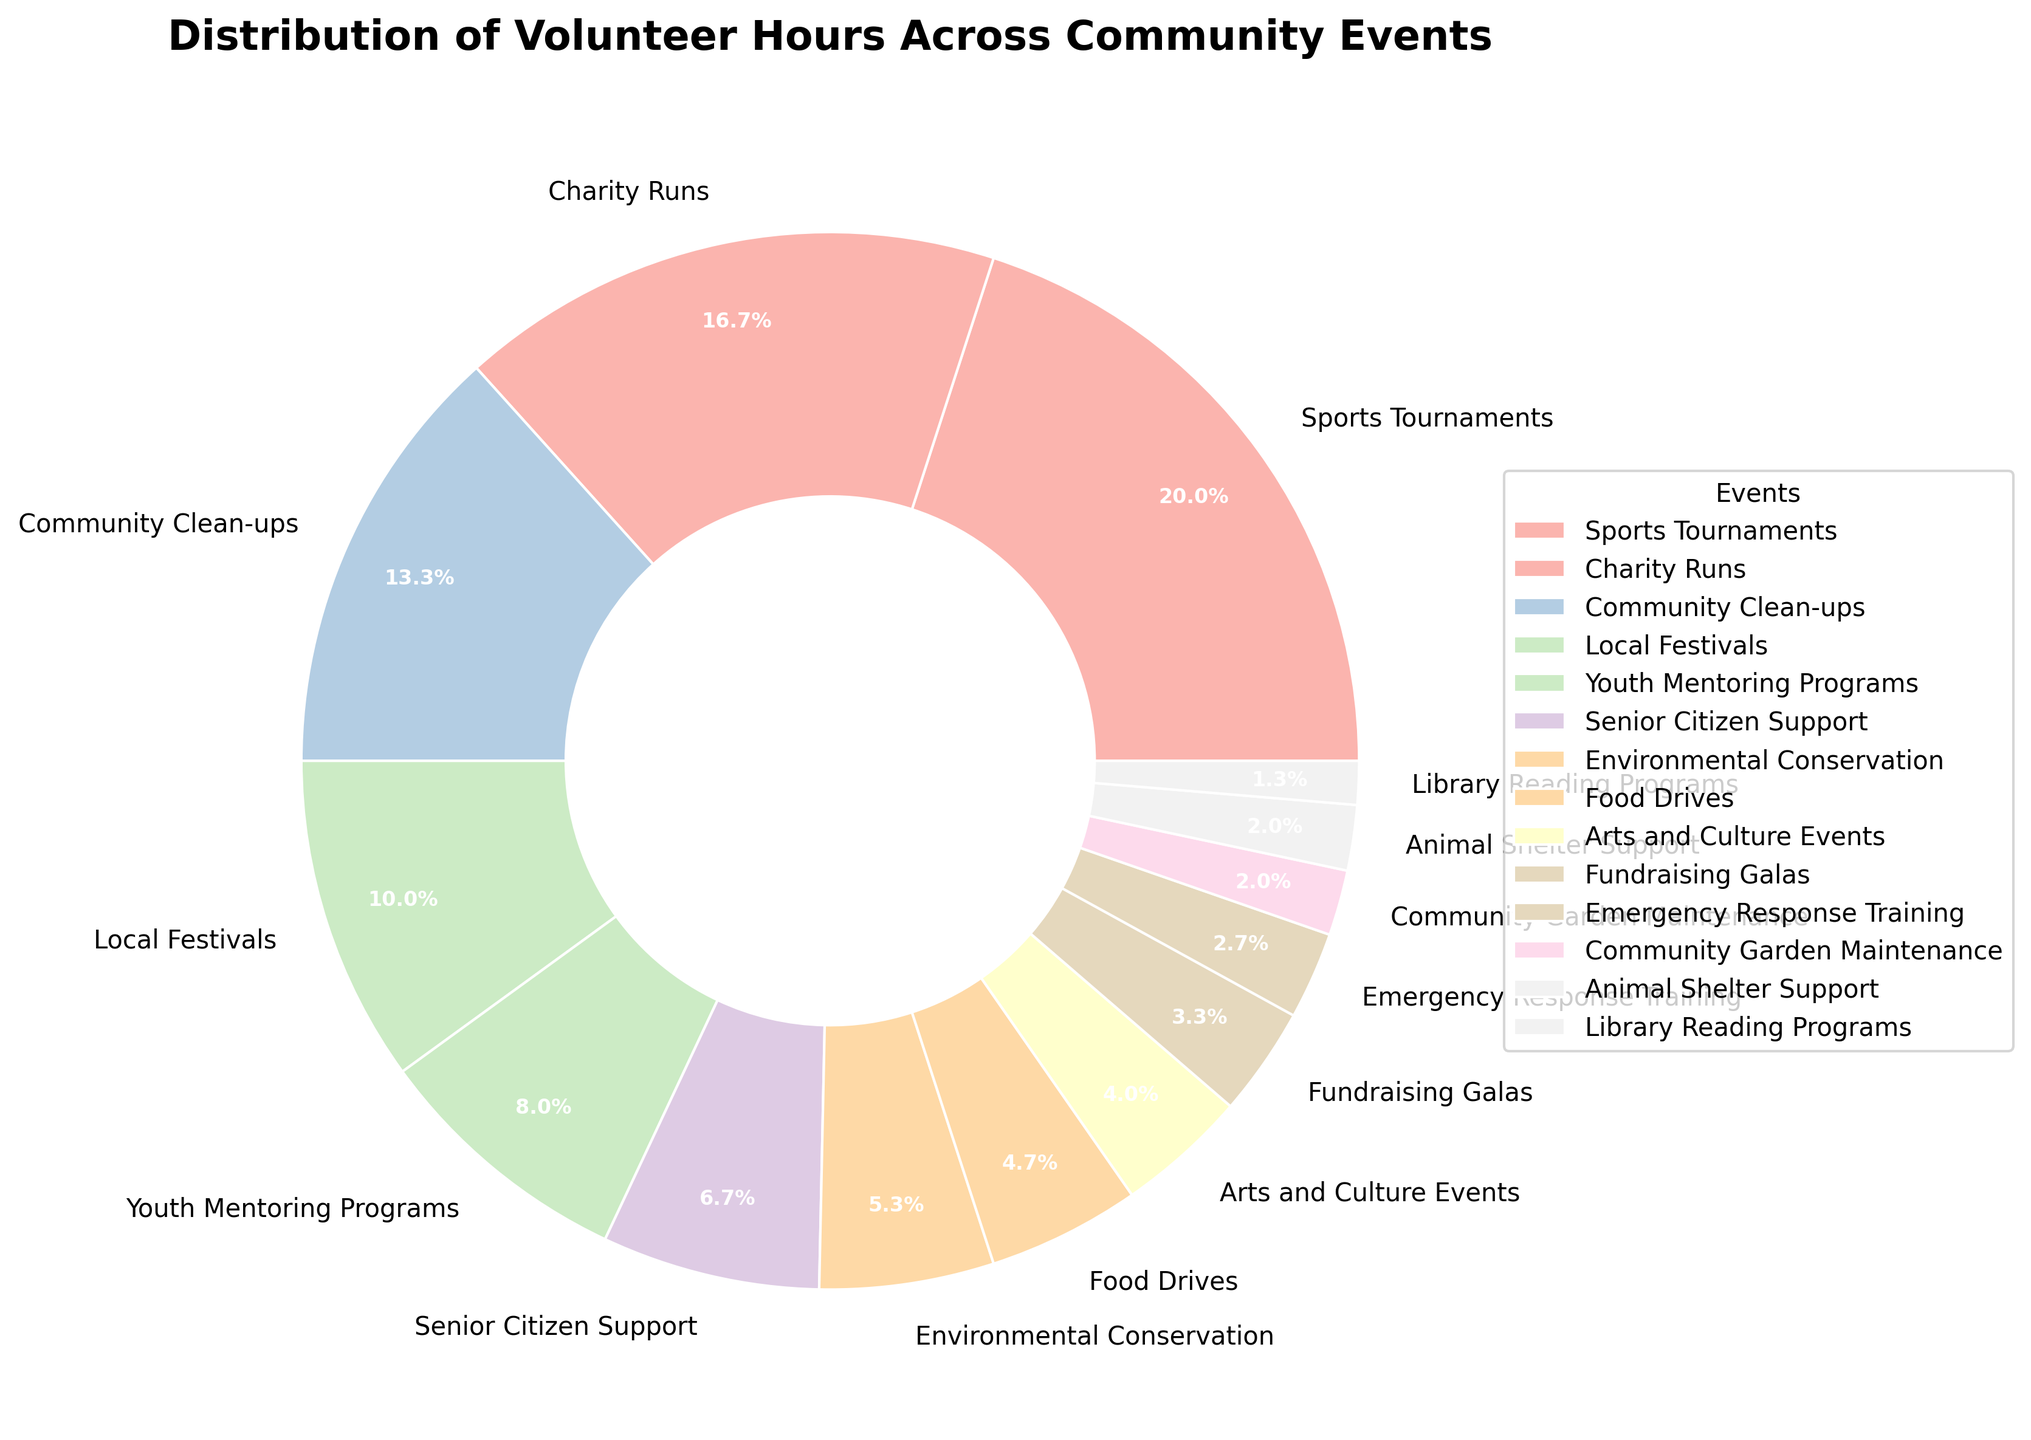What percentage of the total volunteer hours is dedicated to Youth Mentoring Programs? The pie chart displays that Youth Mentoring Programs take up 12% of the total volunteer hours as indicated by the corresponding section labeled with "12.0%".
Answer: 12% Which event received more volunteer hours: Charity Runs or Local Festivals? The pie chart shows that Charity Runs have 25% and Local Festivals have 15% of the volunteer hours, so Charity Runs received more hours.
Answer: Charity Runs What is the combined percentage of volunteer hours for Community Clean-ups and Food Drives? Community Clean-ups have 20% and Food Drives have 7%. Summing these two percentages gives 20% + 7% = 27%.
Answer: 27% Are there any events that received the same amount of volunteer hours? According to the pie chart, Animal Shelter Support and Library Reading Programs received 2% each, indicating that they have the same volunteer hours.
Answer: Yes How does the volunteer time for Environmental Conservation compare to Emergency Response Training? The pie chart shows Environmental Conservation at 8% and Emergency Response Training at 4%. So, Environmental Conservation received double the volunteer hours of Emergency Response Training.
Answer: Environmental Conservation received more Which community event has the least volunteer hours? From the pie chart, Library Reading Programs have the smallest section, indicating they have the least volunteer hours at 2%.
Answer: Library Reading Programs What fraction of the total volunteer hours is spent on Sports Tournaments and how does it compare to the time spent on Arts and Culture Events? Sports Tournaments take up 30% while Arts and Culture Events take up 6%. The fraction for Sports Tournaments is 30%/100% = 3/10 and is much higher compared to 6% for Arts and Culture Events.
Answer: Higher What are the top three events with the highest percentage of volunteer hours? The pie chart shows the largest sections which are Sports Tournaments (30%), Charity Runs (25%), and Community Clean-ups (20%). These are the three highest percentages.
Answer: Sports Tournaments, Charity Runs, Community Clean-ups Calculate the total percentage of volunteer hours dedicated to activities related to environmental and animal support (Animal Shelter Support and Environmental Conservation). From the pie chart, Animal Shelter Support is 2% and Environmental Conservation is 8%. The combined percentage is 2% + 8% = 10%.
Answer: 10% 